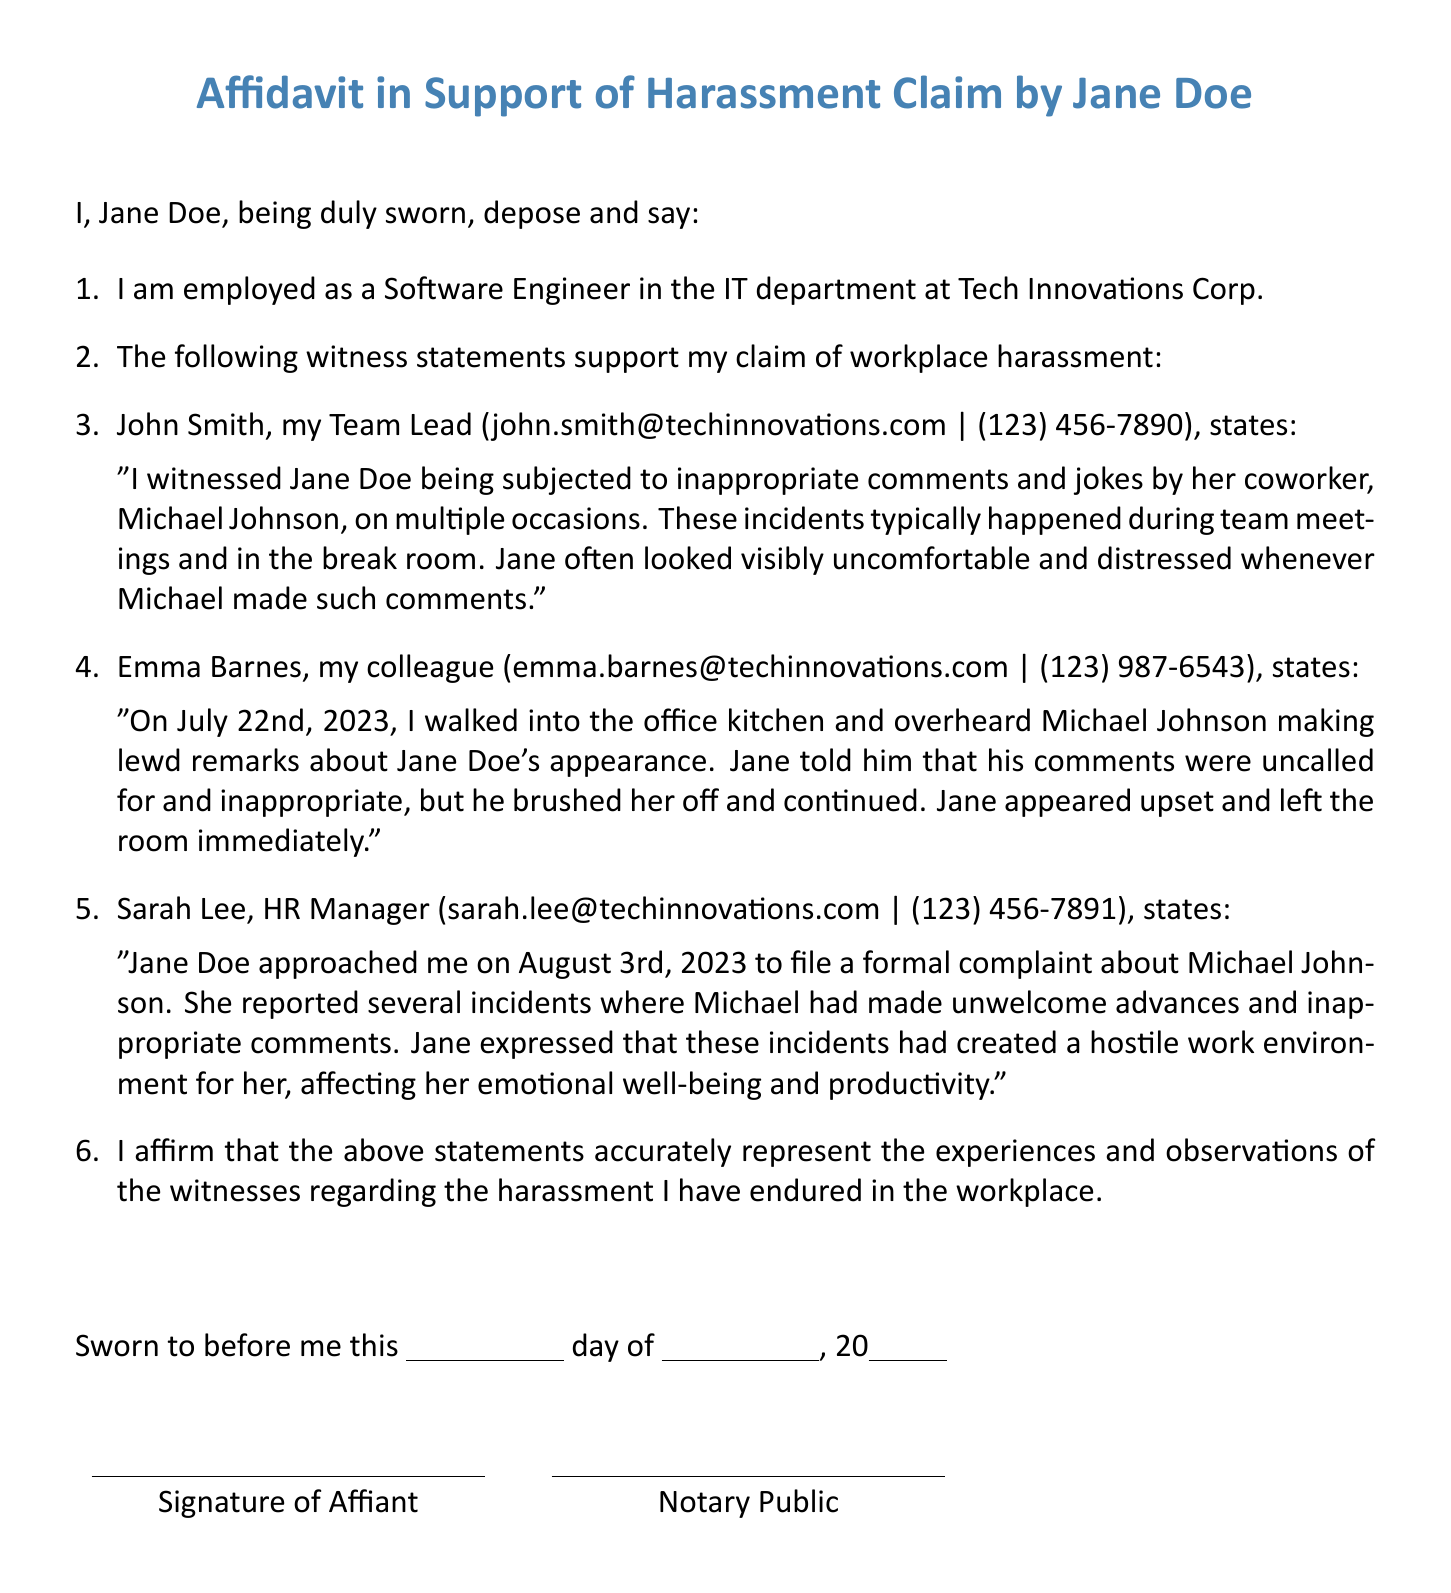What is the employee's name? The employee's name is mentioned at the beginning of the affidavit as Jane Doe.
Answer: Jane Doe What is the title of the document? The title of the document is stated prominently at the top of the affidavit.
Answer: Affidavit in Support of Harassment Claim by Jane Doe Who is the first witness mentioned? The first witness is identified in the list of witness statements supporting the affidavit.
Answer: John Smith What is John Smith's relationship to the employee? John Smith's relationship to the employee is specified in the document as her Team Lead.
Answer: Team Lead On what date did Emma Barnes witness an incident? The date of the incident observed by Emma Barnes is explicitly mentioned in her statement within the affidavit.
Answer: July 22nd, 2023 What was the nature of Michael Johnson's comments according to Emma Barnes? The affidavit details the comments made by Michael Johnson as being lewd remarks about Jane Doe's appearance.
Answer: Lewd remarks How did Jane Doe react to Michael Johnson's comments? Jane Doe's reaction is described in Emma Barnes's statement regarding the inappropriate comments.
Answer: Upset Who did Jane Doe approach to file a complaint? The document identifies the person Jane Doe approached to file a complaint about the harassment.
Answer: Sarah Lee What did Sarah Lee state about the harassment described by Jane Doe? Sarah Lee's statement summarizes Jane Doe's feelings and the impact of the harassment on her work.
Answer: Hostile work environment 